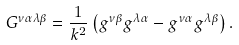<formula> <loc_0><loc_0><loc_500><loc_500>G ^ { \nu \alpha \lambda \beta } = \frac { 1 } { k ^ { 2 } } \left ( g ^ { \nu \beta } g ^ { \lambda \alpha } - g ^ { \nu \alpha } g ^ { \lambda \beta } \right ) .</formula> 